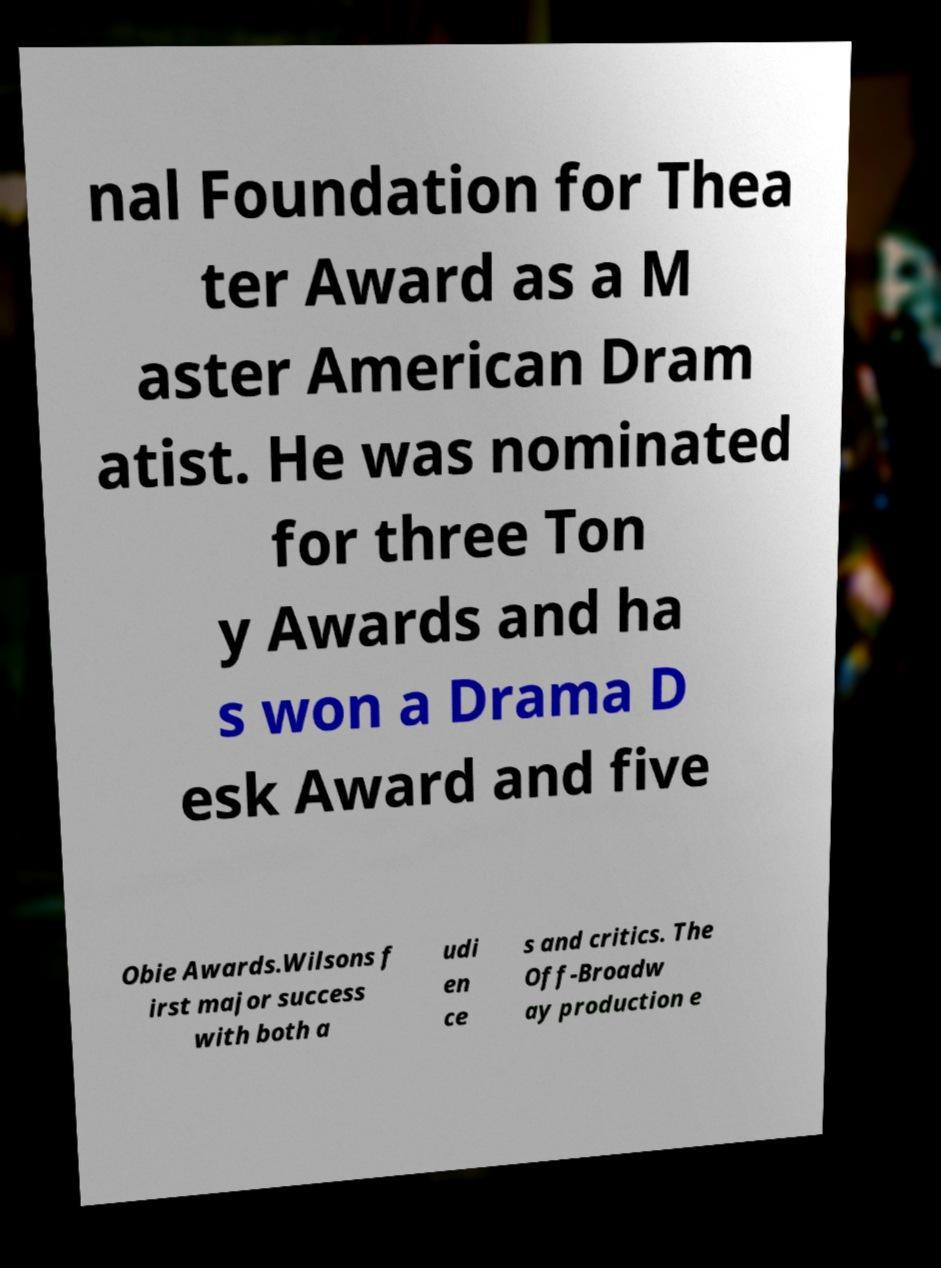Could you extract and type out the text from this image? nal Foundation for Thea ter Award as a M aster American Dram atist. He was nominated for three Ton y Awards and ha s won a Drama D esk Award and five Obie Awards.Wilsons f irst major success with both a udi en ce s and critics. The Off-Broadw ay production e 